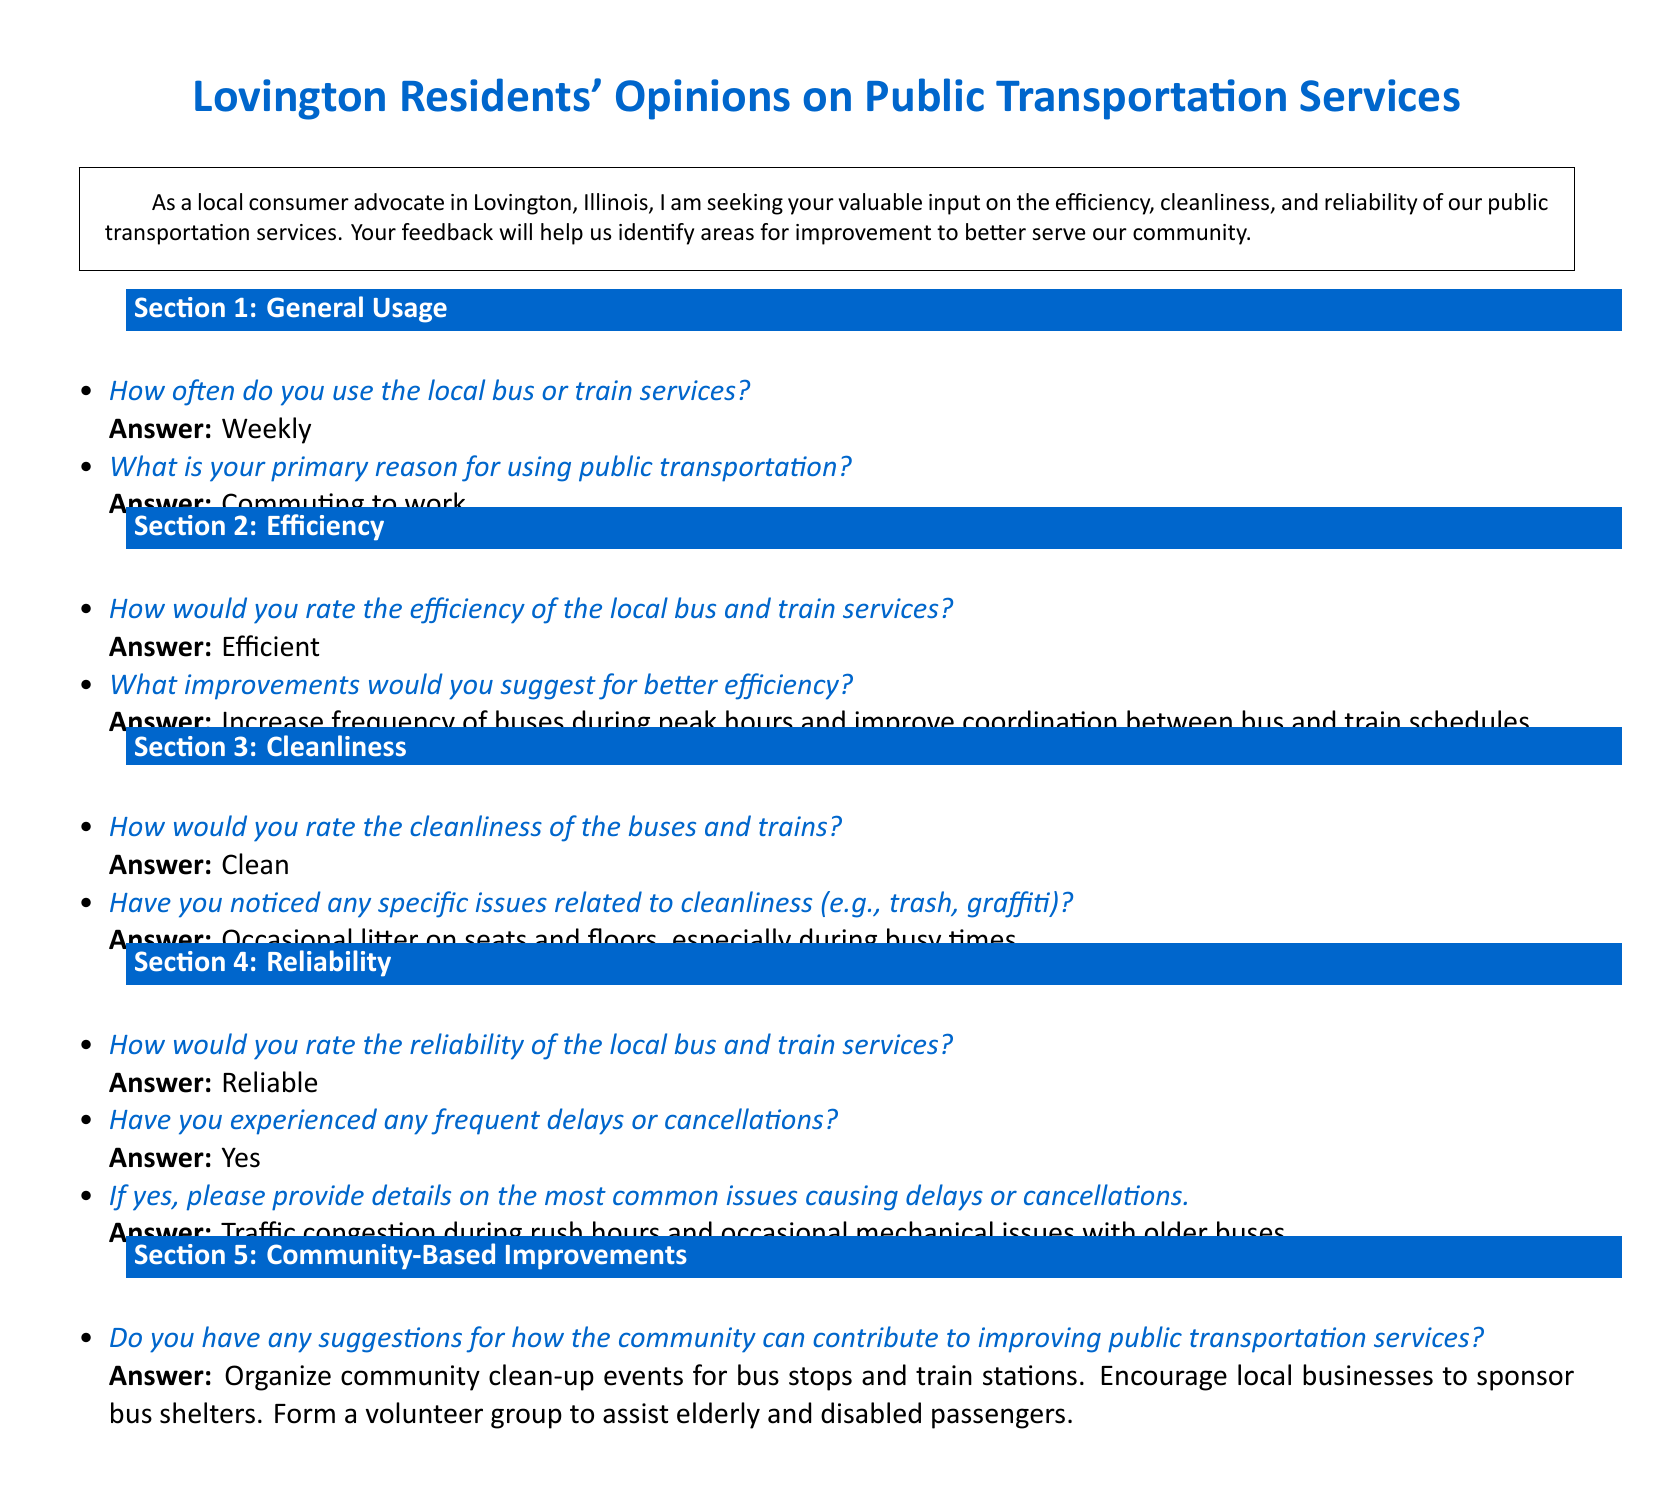How often do residents use local transportation? The survey indicates that residents typically use local transportation on a weekly basis.
Answer: Weekly What is the primary reason for using public transportation? The main purpose for using public transport as stated in the survey is for commuting to work.
Answer: Commuting to work How do residents rate the efficiency of local services? Residents describe the efficiency of local bus and train services as efficient according to survey responses.
Answer: Efficient What is the cleanliness rating of buses and trains? According to the survey responses, residents consider the buses and trains to be clean.
Answer: Clean What specific cleanliness issue is mentioned? The survey points out that there is occasional litter on seats and floors during busy times.
Answer: Occasional litter on seats and floors What do residents perceive about the reliability of public transportation? Survey responses clearly indicate that the local bus and train services are considered reliable by the residents.
Answer: Reliable What common issues cause delays or cancellations? Residents report that traffic congestion during rush hours and mechanical issues with older buses frequently cause delays or cancellations.
Answer: Traffic congestion and mechanical issues What community contribution is suggested for improvement? One suggestion from the survey is to organize community clean-up events for bus stops and train stations.
Answer: Organize community clean-up events What do residents suggest for involving local businesses in transportation services? The survey response includes encouraging local businesses to sponsor bus shelters as a method of involvement.
Answer: Sponsor bus shelters 